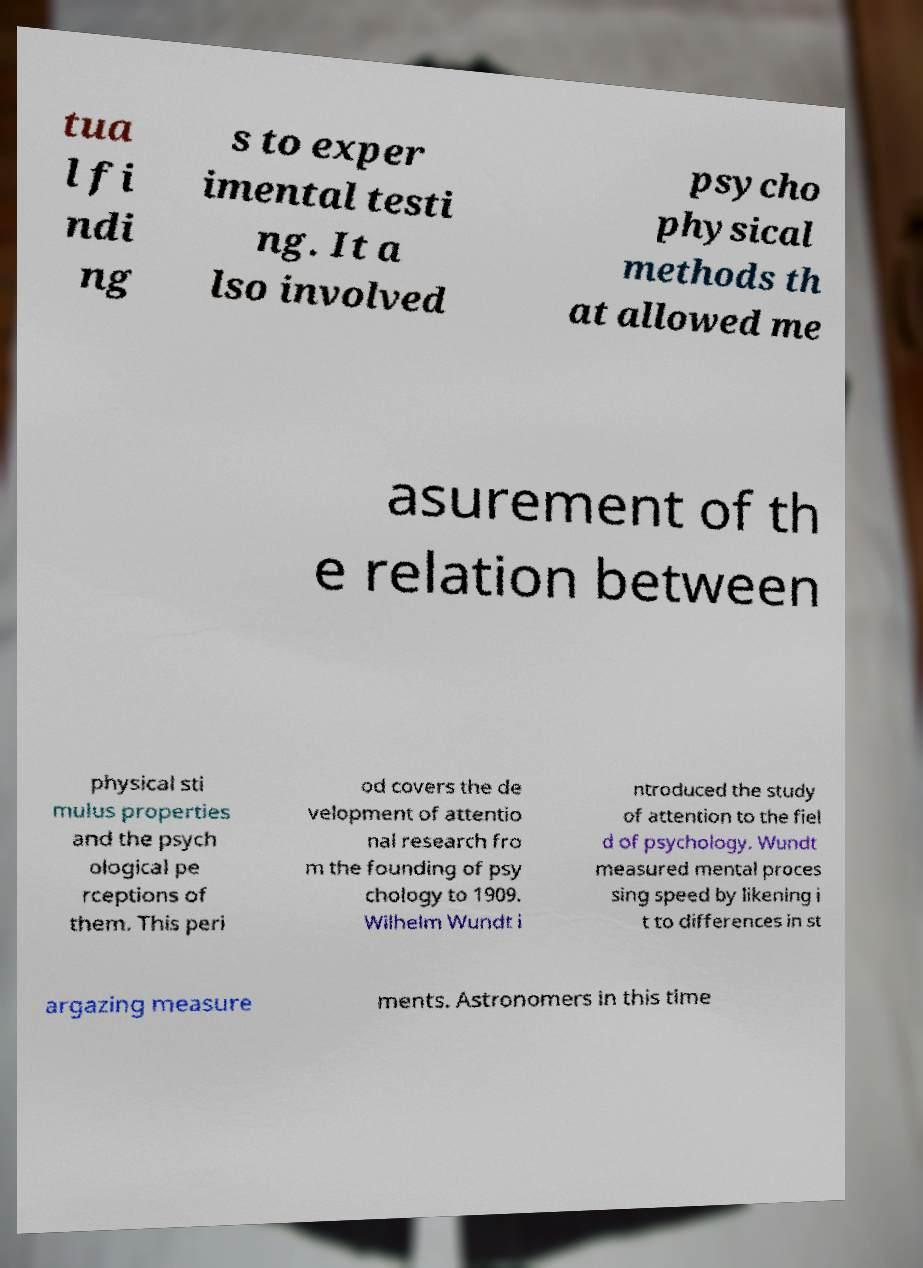Please identify and transcribe the text found in this image. tua l fi ndi ng s to exper imental testi ng. It a lso involved psycho physical methods th at allowed me asurement of th e relation between physical sti mulus properties and the psych ological pe rceptions of them. This peri od covers the de velopment of attentio nal research fro m the founding of psy chology to 1909. Wilhelm Wundt i ntroduced the study of attention to the fiel d of psychology. Wundt measured mental proces sing speed by likening i t to differences in st argazing measure ments. Astronomers in this time 